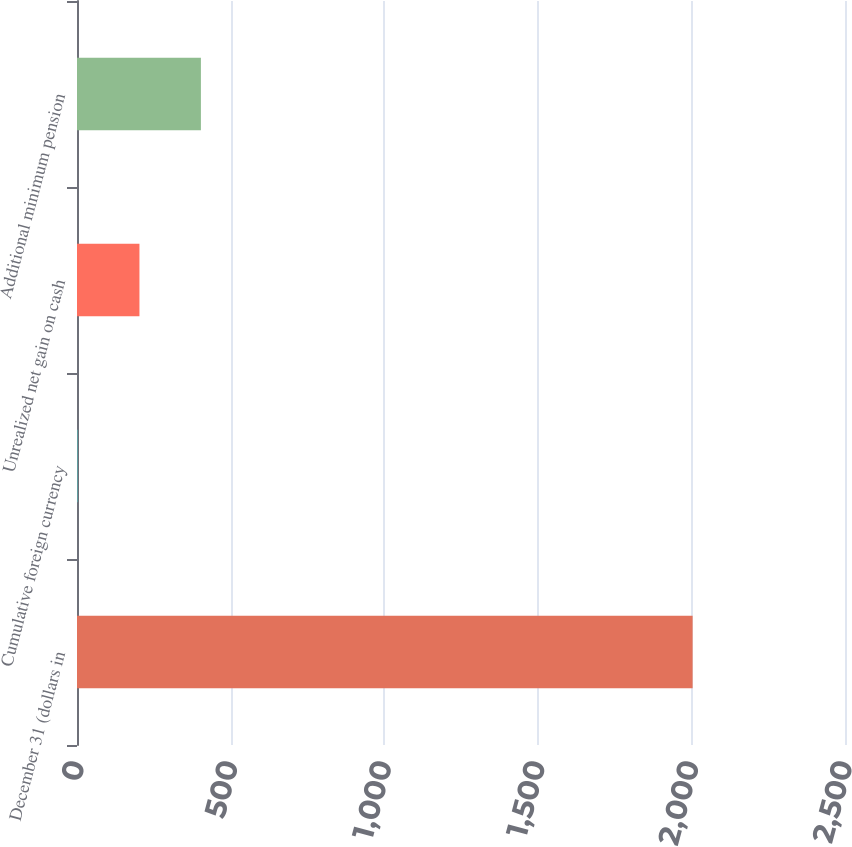<chart> <loc_0><loc_0><loc_500><loc_500><bar_chart><fcel>December 31 (dollars in<fcel>Cumulative foreign currency<fcel>Unrealized net gain on cash<fcel>Additional minimum pension<nl><fcel>2004<fcel>3.2<fcel>203.28<fcel>403.36<nl></chart> 